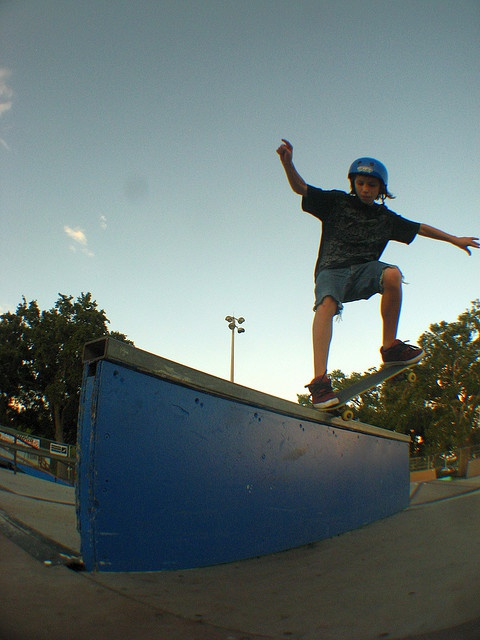Describe the objects in this image and their specific colors. I can see people in gray, black, maroon, and brown tones and skateboard in gray, black, olive, maroon, and darkgreen tones in this image. 